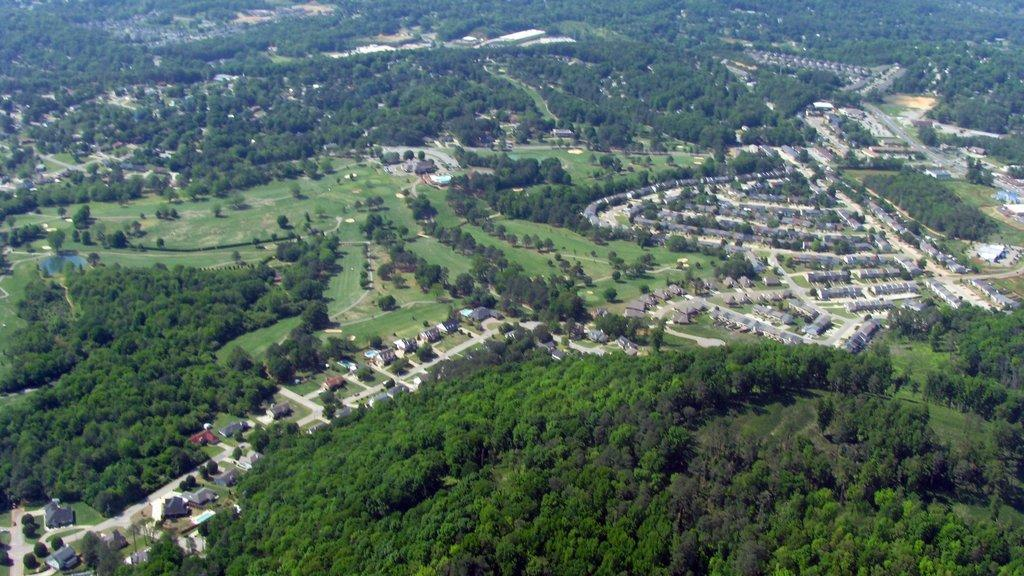What type of view is depicted in the image? The image is an aerial view. What structures can be seen in the image? There are houses in the image. What type of vegetation is present in the image? There are trees in the image. What can be seen on the ground in the image? The ground is visible in the image. What type of transportation infrastructure is present in the image? There are roads in the image. What type of vehicles can be seen in the image? Vehicles are present in the image. What type of recreational feature is present in the image? There is a pool in the image. What type of tooth is visible in the image? There is no tooth visible in the image. What type of spark can be seen coming from the vehicles in the image? There is no spark visible in the image; the vehicles are not shown in motion or with any visible sparks. 